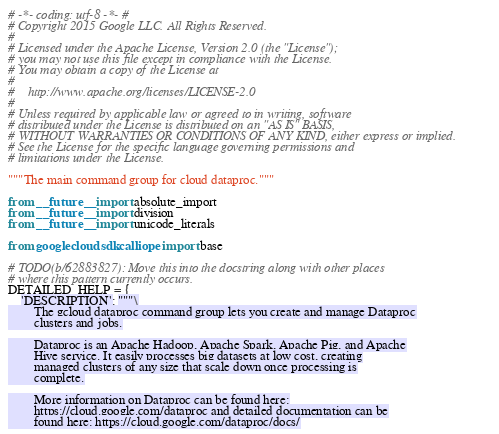Convert code to text. <code><loc_0><loc_0><loc_500><loc_500><_Python_># -*- coding: utf-8 -*- #
# Copyright 2015 Google LLC. All Rights Reserved.
#
# Licensed under the Apache License, Version 2.0 (the "License");
# you may not use this file except in compliance with the License.
# You may obtain a copy of the License at
#
#    http://www.apache.org/licenses/LICENSE-2.0
#
# Unless required by applicable law or agreed to in writing, software
# distributed under the License is distributed on an "AS IS" BASIS,
# WITHOUT WARRANTIES OR CONDITIONS OF ANY KIND, either express or implied.
# See the License for the specific language governing permissions and
# limitations under the License.

"""The main command group for cloud dataproc."""

from __future__ import absolute_import
from __future__ import division
from __future__ import unicode_literals

from googlecloudsdk.calliope import base

# TODO(b/62883827): Move this into the docstring along with other places
# where this pattern currently occurs.
DETAILED_HELP = {
    'DESCRIPTION': """\
        The gcloud dataproc command group lets you create and manage Dataproc
        clusters and jobs.

        Dataproc is an Apache Hadoop, Apache Spark, Apache Pig, and Apache
        Hive service. It easily processes big datasets at low cost, creating
        managed clusters of any size that scale down once processing is
        complete.

        More information on Dataproc can be found here:
        https://cloud.google.com/dataproc and detailed documentation can be
        found here: https://cloud.google.com/dataproc/docs/
</code> 